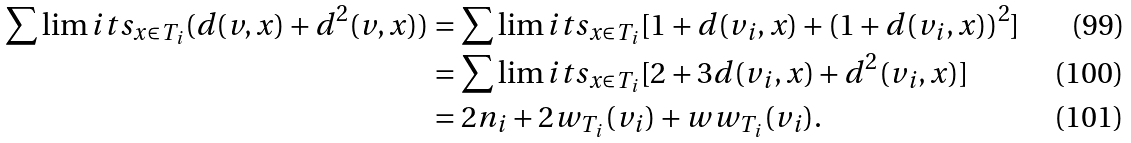Convert formula to latex. <formula><loc_0><loc_0><loc_500><loc_500>\sum \lim i t s _ { x \in T _ { i } } ( d ( v , x ) + d ^ { 2 } ( v , x ) ) & = \sum \lim i t s _ { x \in T _ { i } } [ 1 + d ( v _ { i } , x ) + ( 1 + d ( v _ { i } , x ) ) ^ { 2 } ] \\ & = \sum \lim i t s _ { x \in T _ { i } } [ 2 + 3 d ( v _ { i } , x ) + d ^ { 2 } ( v _ { i } , x ) ] \\ & = 2 n _ { i } + 2 w _ { T _ { i } } ( v _ { i } ) + w w _ { T _ { i } } ( v _ { i } ) .</formula> 